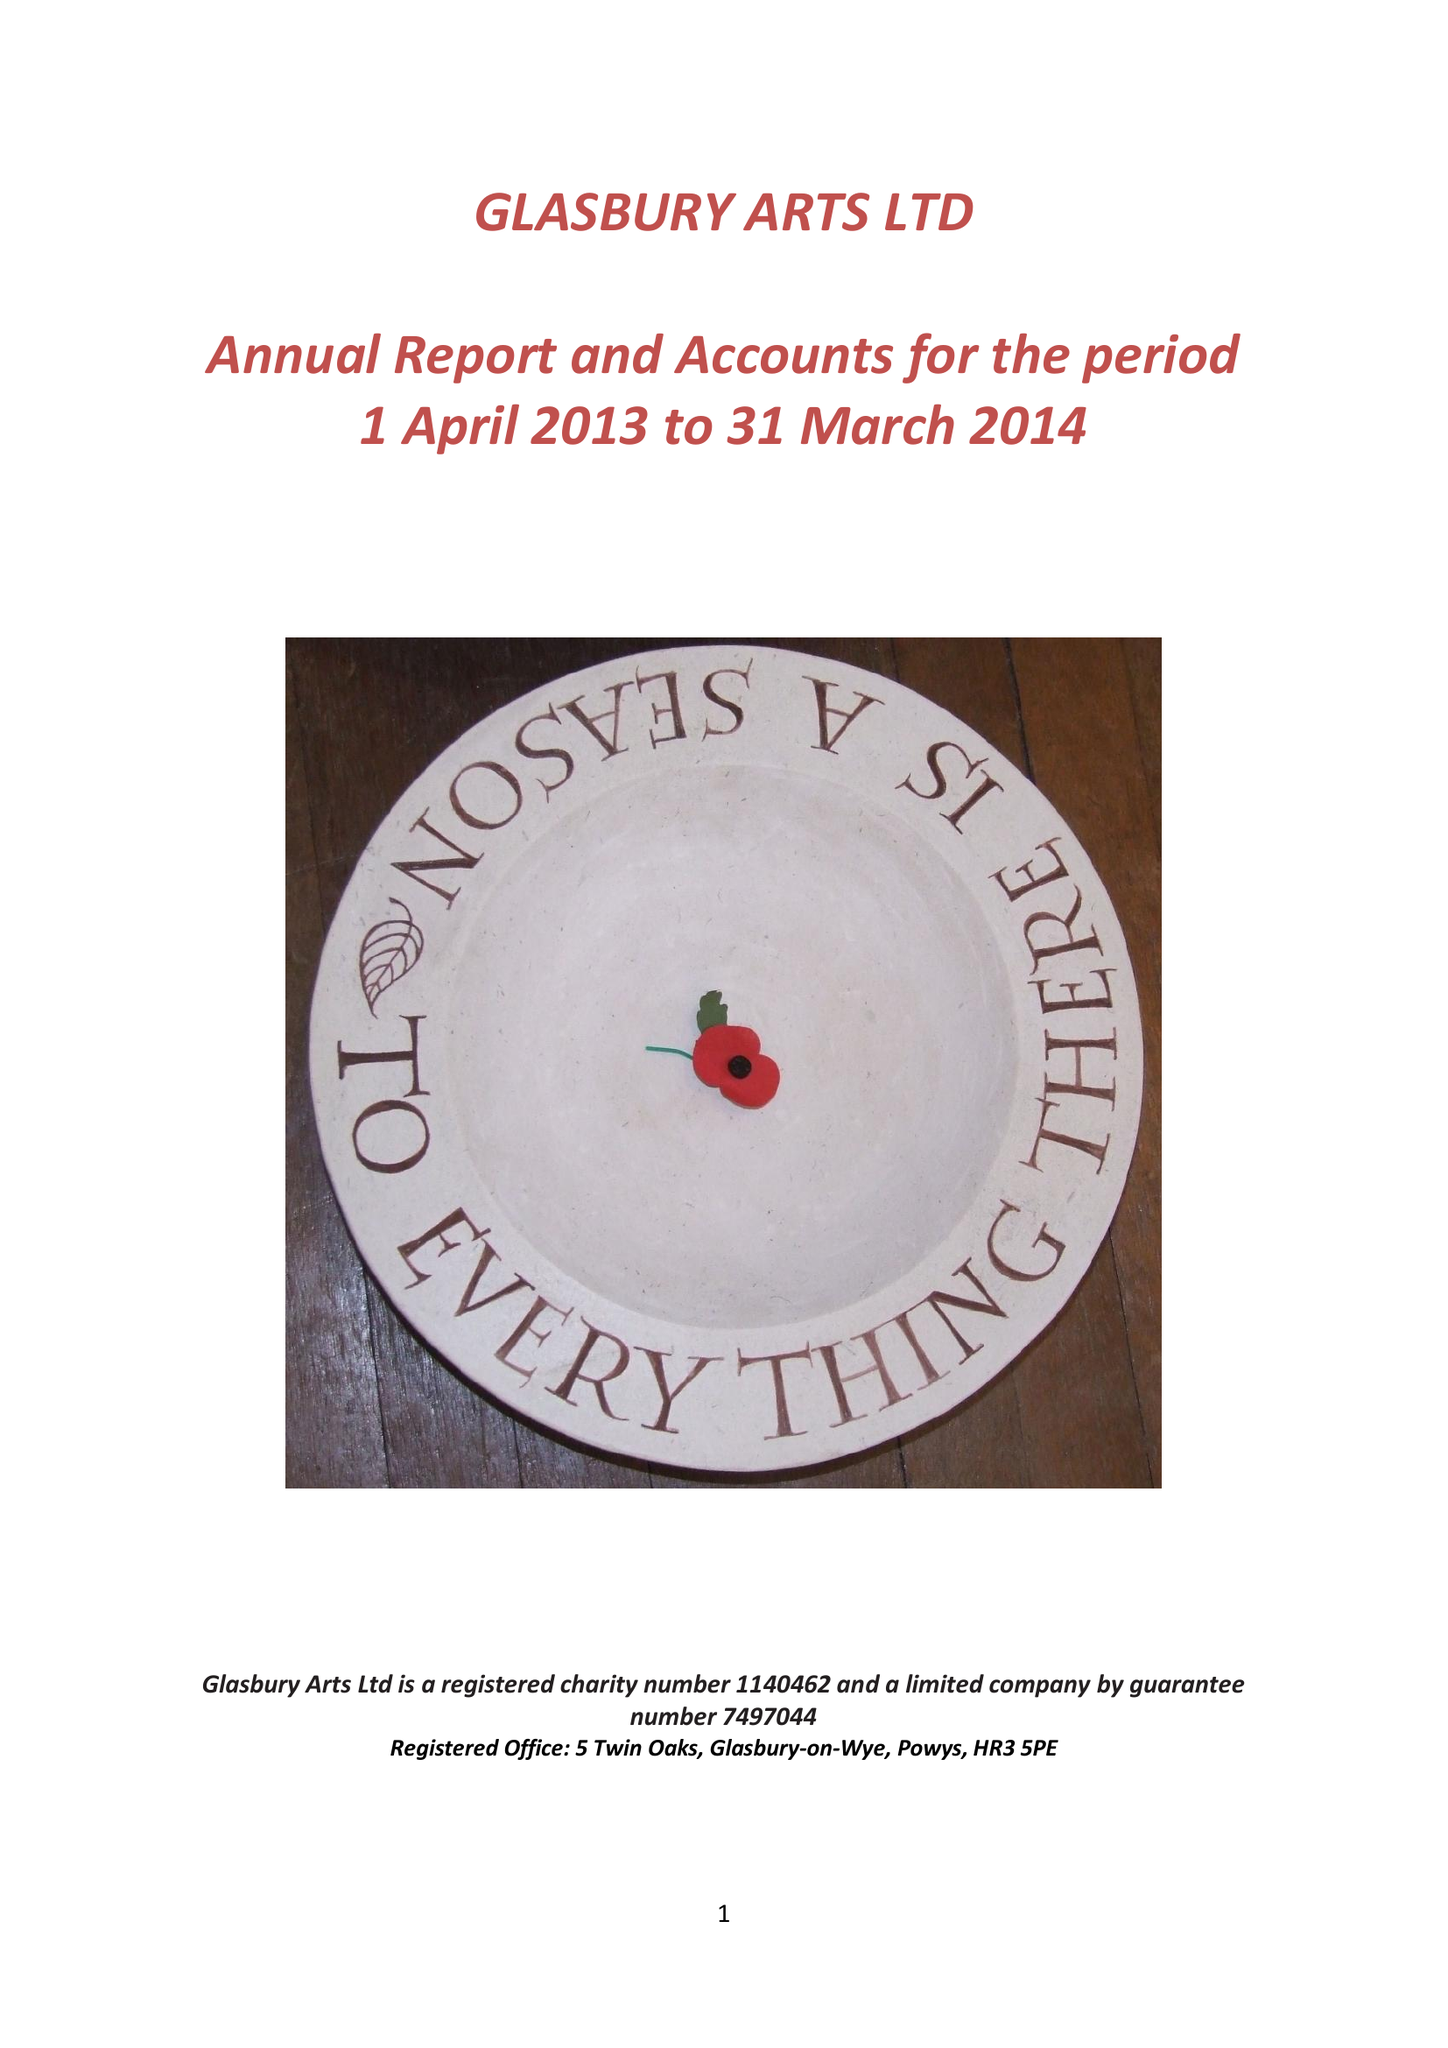What is the value for the address__street_line?
Answer the question using a single word or phrase. None 